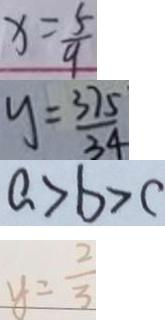<formula> <loc_0><loc_0><loc_500><loc_500>x = \frac { 5 } { 9 } 
 y = \frac { 3 7 5 } { 3 4 } 
 a > b > c 
 y = \frac { 2 } { 3 }</formula> 